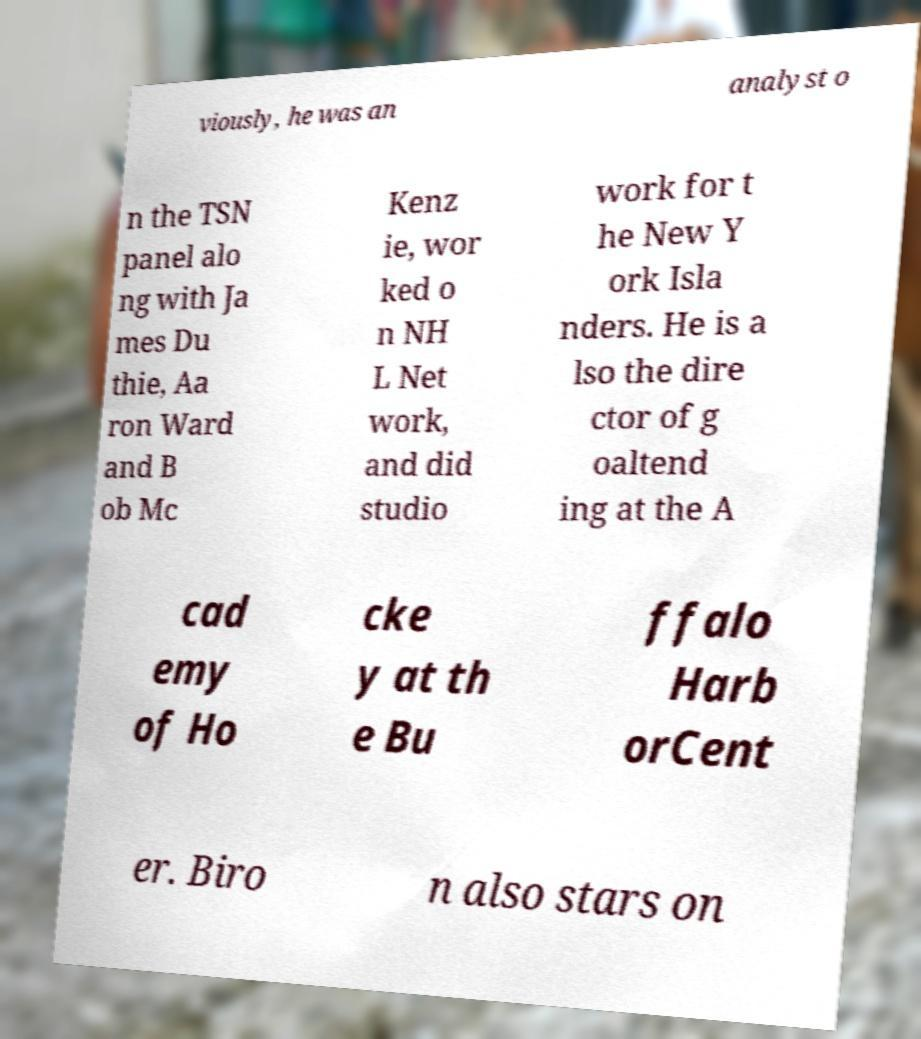Please identify and transcribe the text found in this image. viously, he was an analyst o n the TSN panel alo ng with Ja mes Du thie, Aa ron Ward and B ob Mc Kenz ie, wor ked o n NH L Net work, and did studio work for t he New Y ork Isla nders. He is a lso the dire ctor of g oaltend ing at the A cad emy of Ho cke y at th e Bu ffalo Harb orCent er. Biro n also stars on 